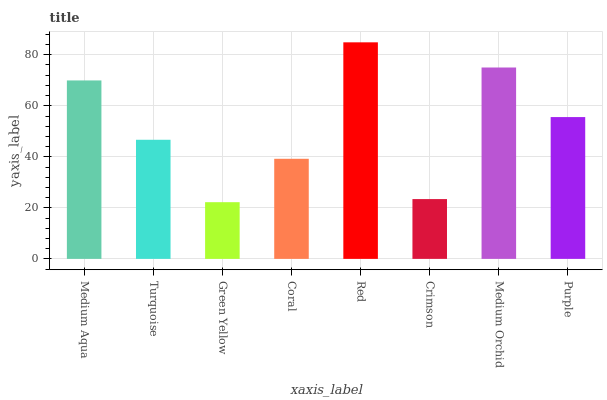Is Green Yellow the minimum?
Answer yes or no. Yes. Is Red the maximum?
Answer yes or no. Yes. Is Turquoise the minimum?
Answer yes or no. No. Is Turquoise the maximum?
Answer yes or no. No. Is Medium Aqua greater than Turquoise?
Answer yes or no. Yes. Is Turquoise less than Medium Aqua?
Answer yes or no. Yes. Is Turquoise greater than Medium Aqua?
Answer yes or no. No. Is Medium Aqua less than Turquoise?
Answer yes or no. No. Is Purple the high median?
Answer yes or no. Yes. Is Turquoise the low median?
Answer yes or no. Yes. Is Green Yellow the high median?
Answer yes or no. No. Is Coral the low median?
Answer yes or no. No. 